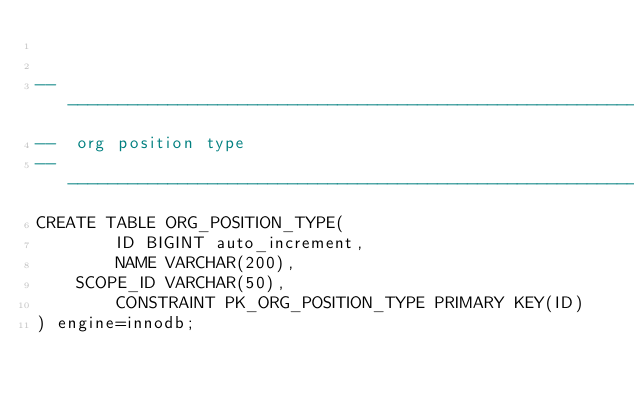<code> <loc_0><loc_0><loc_500><loc_500><_SQL_>

-------------------------------------------------------------------------------
--  org position type
-------------------------------------------------------------------------------
CREATE TABLE ORG_POSITION_TYPE(
        ID BIGINT auto_increment,
        NAME VARCHAR(200),
	SCOPE_ID VARCHAR(50),
        CONSTRAINT PK_ORG_POSITION_TYPE PRIMARY KEY(ID)
) engine=innodb;

</code> 